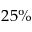<formula> <loc_0><loc_0><loc_500><loc_500>2 5 \%</formula> 